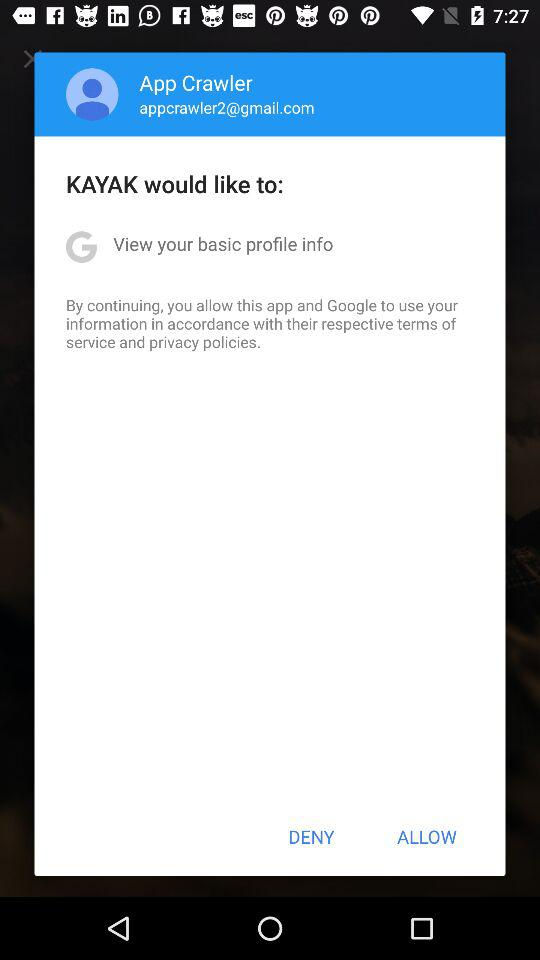What is the username? The username is "App Crawler". 